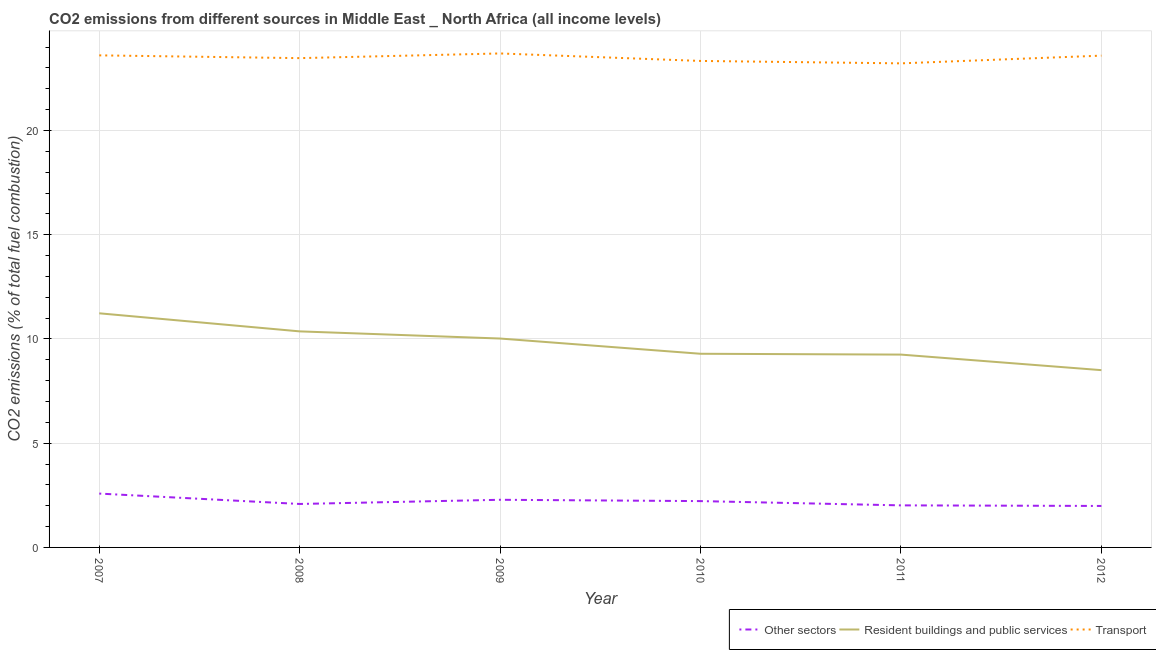Is the number of lines equal to the number of legend labels?
Ensure brevity in your answer.  Yes. What is the percentage of co2 emissions from resident buildings and public services in 2007?
Provide a succinct answer. 11.23. Across all years, what is the maximum percentage of co2 emissions from resident buildings and public services?
Provide a short and direct response. 11.23. Across all years, what is the minimum percentage of co2 emissions from resident buildings and public services?
Provide a succinct answer. 8.5. In which year was the percentage of co2 emissions from transport maximum?
Offer a terse response. 2009. In which year was the percentage of co2 emissions from transport minimum?
Offer a very short reply. 2011. What is the total percentage of co2 emissions from other sectors in the graph?
Provide a short and direct response. 13.18. What is the difference between the percentage of co2 emissions from transport in 2009 and that in 2011?
Make the answer very short. 0.48. What is the difference between the percentage of co2 emissions from other sectors in 2007 and the percentage of co2 emissions from transport in 2009?
Provide a succinct answer. -21.11. What is the average percentage of co2 emissions from other sectors per year?
Give a very brief answer. 2.2. In the year 2008, what is the difference between the percentage of co2 emissions from transport and percentage of co2 emissions from resident buildings and public services?
Offer a terse response. 13.11. What is the ratio of the percentage of co2 emissions from resident buildings and public services in 2009 to that in 2010?
Your answer should be very brief. 1.08. Is the percentage of co2 emissions from resident buildings and public services in 2007 less than that in 2011?
Ensure brevity in your answer.  No. Is the difference between the percentage of co2 emissions from other sectors in 2007 and 2009 greater than the difference between the percentage of co2 emissions from transport in 2007 and 2009?
Provide a succinct answer. Yes. What is the difference between the highest and the second highest percentage of co2 emissions from transport?
Make the answer very short. 0.09. What is the difference between the highest and the lowest percentage of co2 emissions from transport?
Keep it short and to the point. 0.48. In how many years, is the percentage of co2 emissions from resident buildings and public services greater than the average percentage of co2 emissions from resident buildings and public services taken over all years?
Provide a succinct answer. 3. Is it the case that in every year, the sum of the percentage of co2 emissions from other sectors and percentage of co2 emissions from resident buildings and public services is greater than the percentage of co2 emissions from transport?
Give a very brief answer. No. Does the percentage of co2 emissions from transport monotonically increase over the years?
Your answer should be very brief. No. Is the percentage of co2 emissions from transport strictly greater than the percentage of co2 emissions from other sectors over the years?
Offer a terse response. Yes. Is the percentage of co2 emissions from other sectors strictly less than the percentage of co2 emissions from transport over the years?
Provide a succinct answer. Yes. How many lines are there?
Ensure brevity in your answer.  3. What is the difference between two consecutive major ticks on the Y-axis?
Give a very brief answer. 5. Does the graph contain any zero values?
Ensure brevity in your answer.  No. Where does the legend appear in the graph?
Your answer should be very brief. Bottom right. How many legend labels are there?
Give a very brief answer. 3. What is the title of the graph?
Your response must be concise. CO2 emissions from different sources in Middle East _ North Africa (all income levels). What is the label or title of the X-axis?
Provide a succinct answer. Year. What is the label or title of the Y-axis?
Offer a terse response. CO2 emissions (% of total fuel combustion). What is the CO2 emissions (% of total fuel combustion) of Other sectors in 2007?
Provide a short and direct response. 2.58. What is the CO2 emissions (% of total fuel combustion) in Resident buildings and public services in 2007?
Your answer should be very brief. 11.23. What is the CO2 emissions (% of total fuel combustion) of Transport in 2007?
Your answer should be very brief. 23.6. What is the CO2 emissions (% of total fuel combustion) of Other sectors in 2008?
Your response must be concise. 2.08. What is the CO2 emissions (% of total fuel combustion) in Resident buildings and public services in 2008?
Make the answer very short. 10.36. What is the CO2 emissions (% of total fuel combustion) of Transport in 2008?
Your response must be concise. 23.47. What is the CO2 emissions (% of total fuel combustion) in Other sectors in 2009?
Give a very brief answer. 2.29. What is the CO2 emissions (% of total fuel combustion) of Resident buildings and public services in 2009?
Keep it short and to the point. 10.02. What is the CO2 emissions (% of total fuel combustion) in Transport in 2009?
Provide a succinct answer. 23.69. What is the CO2 emissions (% of total fuel combustion) in Other sectors in 2010?
Offer a terse response. 2.22. What is the CO2 emissions (% of total fuel combustion) in Resident buildings and public services in 2010?
Ensure brevity in your answer.  9.29. What is the CO2 emissions (% of total fuel combustion) of Transport in 2010?
Make the answer very short. 23.33. What is the CO2 emissions (% of total fuel combustion) in Other sectors in 2011?
Make the answer very short. 2.02. What is the CO2 emissions (% of total fuel combustion) in Resident buildings and public services in 2011?
Offer a terse response. 9.25. What is the CO2 emissions (% of total fuel combustion) of Transport in 2011?
Your answer should be compact. 23.22. What is the CO2 emissions (% of total fuel combustion) of Other sectors in 2012?
Offer a terse response. 1.99. What is the CO2 emissions (% of total fuel combustion) of Resident buildings and public services in 2012?
Make the answer very short. 8.5. What is the CO2 emissions (% of total fuel combustion) in Transport in 2012?
Your answer should be very brief. 23.59. Across all years, what is the maximum CO2 emissions (% of total fuel combustion) of Other sectors?
Your answer should be compact. 2.58. Across all years, what is the maximum CO2 emissions (% of total fuel combustion) in Resident buildings and public services?
Provide a succinct answer. 11.23. Across all years, what is the maximum CO2 emissions (% of total fuel combustion) in Transport?
Ensure brevity in your answer.  23.69. Across all years, what is the minimum CO2 emissions (% of total fuel combustion) of Other sectors?
Offer a terse response. 1.99. Across all years, what is the minimum CO2 emissions (% of total fuel combustion) of Resident buildings and public services?
Make the answer very short. 8.5. Across all years, what is the minimum CO2 emissions (% of total fuel combustion) in Transport?
Offer a very short reply. 23.22. What is the total CO2 emissions (% of total fuel combustion) of Other sectors in the graph?
Offer a very short reply. 13.18. What is the total CO2 emissions (% of total fuel combustion) in Resident buildings and public services in the graph?
Ensure brevity in your answer.  58.65. What is the total CO2 emissions (% of total fuel combustion) in Transport in the graph?
Provide a short and direct response. 140.91. What is the difference between the CO2 emissions (% of total fuel combustion) in Other sectors in 2007 and that in 2008?
Ensure brevity in your answer.  0.5. What is the difference between the CO2 emissions (% of total fuel combustion) in Resident buildings and public services in 2007 and that in 2008?
Your response must be concise. 0.87. What is the difference between the CO2 emissions (% of total fuel combustion) of Transport in 2007 and that in 2008?
Your response must be concise. 0.13. What is the difference between the CO2 emissions (% of total fuel combustion) in Other sectors in 2007 and that in 2009?
Keep it short and to the point. 0.3. What is the difference between the CO2 emissions (% of total fuel combustion) in Resident buildings and public services in 2007 and that in 2009?
Offer a very short reply. 1.21. What is the difference between the CO2 emissions (% of total fuel combustion) in Transport in 2007 and that in 2009?
Provide a succinct answer. -0.09. What is the difference between the CO2 emissions (% of total fuel combustion) in Other sectors in 2007 and that in 2010?
Your answer should be very brief. 0.36. What is the difference between the CO2 emissions (% of total fuel combustion) of Resident buildings and public services in 2007 and that in 2010?
Ensure brevity in your answer.  1.94. What is the difference between the CO2 emissions (% of total fuel combustion) in Transport in 2007 and that in 2010?
Keep it short and to the point. 0.27. What is the difference between the CO2 emissions (% of total fuel combustion) in Other sectors in 2007 and that in 2011?
Your answer should be very brief. 0.56. What is the difference between the CO2 emissions (% of total fuel combustion) of Resident buildings and public services in 2007 and that in 2011?
Offer a terse response. 1.98. What is the difference between the CO2 emissions (% of total fuel combustion) of Transport in 2007 and that in 2011?
Give a very brief answer. 0.38. What is the difference between the CO2 emissions (% of total fuel combustion) of Other sectors in 2007 and that in 2012?
Offer a terse response. 0.59. What is the difference between the CO2 emissions (% of total fuel combustion) of Resident buildings and public services in 2007 and that in 2012?
Provide a short and direct response. 2.73. What is the difference between the CO2 emissions (% of total fuel combustion) of Transport in 2007 and that in 2012?
Ensure brevity in your answer.  0.01. What is the difference between the CO2 emissions (% of total fuel combustion) of Other sectors in 2008 and that in 2009?
Provide a succinct answer. -0.2. What is the difference between the CO2 emissions (% of total fuel combustion) in Resident buildings and public services in 2008 and that in 2009?
Make the answer very short. 0.34. What is the difference between the CO2 emissions (% of total fuel combustion) of Transport in 2008 and that in 2009?
Offer a terse response. -0.22. What is the difference between the CO2 emissions (% of total fuel combustion) in Other sectors in 2008 and that in 2010?
Your response must be concise. -0.14. What is the difference between the CO2 emissions (% of total fuel combustion) in Resident buildings and public services in 2008 and that in 2010?
Provide a succinct answer. 1.07. What is the difference between the CO2 emissions (% of total fuel combustion) of Transport in 2008 and that in 2010?
Keep it short and to the point. 0.13. What is the difference between the CO2 emissions (% of total fuel combustion) of Other sectors in 2008 and that in 2011?
Your answer should be compact. 0.07. What is the difference between the CO2 emissions (% of total fuel combustion) in Resident buildings and public services in 2008 and that in 2011?
Offer a terse response. 1.11. What is the difference between the CO2 emissions (% of total fuel combustion) in Transport in 2008 and that in 2011?
Make the answer very short. 0.25. What is the difference between the CO2 emissions (% of total fuel combustion) of Other sectors in 2008 and that in 2012?
Give a very brief answer. 0.1. What is the difference between the CO2 emissions (% of total fuel combustion) of Resident buildings and public services in 2008 and that in 2012?
Give a very brief answer. 1.86. What is the difference between the CO2 emissions (% of total fuel combustion) in Transport in 2008 and that in 2012?
Offer a very short reply. -0.12. What is the difference between the CO2 emissions (% of total fuel combustion) in Other sectors in 2009 and that in 2010?
Your response must be concise. 0.06. What is the difference between the CO2 emissions (% of total fuel combustion) of Resident buildings and public services in 2009 and that in 2010?
Make the answer very short. 0.73. What is the difference between the CO2 emissions (% of total fuel combustion) in Transport in 2009 and that in 2010?
Provide a short and direct response. 0.36. What is the difference between the CO2 emissions (% of total fuel combustion) in Other sectors in 2009 and that in 2011?
Provide a succinct answer. 0.27. What is the difference between the CO2 emissions (% of total fuel combustion) in Resident buildings and public services in 2009 and that in 2011?
Keep it short and to the point. 0.77. What is the difference between the CO2 emissions (% of total fuel combustion) in Transport in 2009 and that in 2011?
Your response must be concise. 0.48. What is the difference between the CO2 emissions (% of total fuel combustion) in Other sectors in 2009 and that in 2012?
Your answer should be very brief. 0.3. What is the difference between the CO2 emissions (% of total fuel combustion) of Resident buildings and public services in 2009 and that in 2012?
Give a very brief answer. 1.52. What is the difference between the CO2 emissions (% of total fuel combustion) of Transport in 2009 and that in 2012?
Your answer should be very brief. 0.1. What is the difference between the CO2 emissions (% of total fuel combustion) of Other sectors in 2010 and that in 2011?
Provide a short and direct response. 0.2. What is the difference between the CO2 emissions (% of total fuel combustion) in Resident buildings and public services in 2010 and that in 2011?
Your answer should be very brief. 0.04. What is the difference between the CO2 emissions (% of total fuel combustion) in Transport in 2010 and that in 2011?
Keep it short and to the point. 0.12. What is the difference between the CO2 emissions (% of total fuel combustion) in Other sectors in 2010 and that in 2012?
Give a very brief answer. 0.23. What is the difference between the CO2 emissions (% of total fuel combustion) of Resident buildings and public services in 2010 and that in 2012?
Offer a very short reply. 0.79. What is the difference between the CO2 emissions (% of total fuel combustion) in Transport in 2010 and that in 2012?
Offer a terse response. -0.25. What is the difference between the CO2 emissions (% of total fuel combustion) in Other sectors in 2011 and that in 2012?
Offer a very short reply. 0.03. What is the difference between the CO2 emissions (% of total fuel combustion) in Resident buildings and public services in 2011 and that in 2012?
Keep it short and to the point. 0.75. What is the difference between the CO2 emissions (% of total fuel combustion) in Transport in 2011 and that in 2012?
Offer a terse response. -0.37. What is the difference between the CO2 emissions (% of total fuel combustion) in Other sectors in 2007 and the CO2 emissions (% of total fuel combustion) in Resident buildings and public services in 2008?
Provide a succinct answer. -7.78. What is the difference between the CO2 emissions (% of total fuel combustion) in Other sectors in 2007 and the CO2 emissions (% of total fuel combustion) in Transport in 2008?
Your response must be concise. -20.89. What is the difference between the CO2 emissions (% of total fuel combustion) of Resident buildings and public services in 2007 and the CO2 emissions (% of total fuel combustion) of Transport in 2008?
Offer a terse response. -12.24. What is the difference between the CO2 emissions (% of total fuel combustion) of Other sectors in 2007 and the CO2 emissions (% of total fuel combustion) of Resident buildings and public services in 2009?
Make the answer very short. -7.44. What is the difference between the CO2 emissions (% of total fuel combustion) in Other sectors in 2007 and the CO2 emissions (% of total fuel combustion) in Transport in 2009?
Offer a terse response. -21.11. What is the difference between the CO2 emissions (% of total fuel combustion) of Resident buildings and public services in 2007 and the CO2 emissions (% of total fuel combustion) of Transport in 2009?
Make the answer very short. -12.46. What is the difference between the CO2 emissions (% of total fuel combustion) in Other sectors in 2007 and the CO2 emissions (% of total fuel combustion) in Resident buildings and public services in 2010?
Offer a very short reply. -6.71. What is the difference between the CO2 emissions (% of total fuel combustion) in Other sectors in 2007 and the CO2 emissions (% of total fuel combustion) in Transport in 2010?
Give a very brief answer. -20.75. What is the difference between the CO2 emissions (% of total fuel combustion) of Resident buildings and public services in 2007 and the CO2 emissions (% of total fuel combustion) of Transport in 2010?
Keep it short and to the point. -12.1. What is the difference between the CO2 emissions (% of total fuel combustion) of Other sectors in 2007 and the CO2 emissions (% of total fuel combustion) of Resident buildings and public services in 2011?
Offer a very short reply. -6.67. What is the difference between the CO2 emissions (% of total fuel combustion) in Other sectors in 2007 and the CO2 emissions (% of total fuel combustion) in Transport in 2011?
Your answer should be compact. -20.64. What is the difference between the CO2 emissions (% of total fuel combustion) in Resident buildings and public services in 2007 and the CO2 emissions (% of total fuel combustion) in Transport in 2011?
Provide a succinct answer. -11.99. What is the difference between the CO2 emissions (% of total fuel combustion) of Other sectors in 2007 and the CO2 emissions (% of total fuel combustion) of Resident buildings and public services in 2012?
Your answer should be compact. -5.92. What is the difference between the CO2 emissions (% of total fuel combustion) in Other sectors in 2007 and the CO2 emissions (% of total fuel combustion) in Transport in 2012?
Offer a very short reply. -21.01. What is the difference between the CO2 emissions (% of total fuel combustion) in Resident buildings and public services in 2007 and the CO2 emissions (% of total fuel combustion) in Transport in 2012?
Your answer should be very brief. -12.36. What is the difference between the CO2 emissions (% of total fuel combustion) in Other sectors in 2008 and the CO2 emissions (% of total fuel combustion) in Resident buildings and public services in 2009?
Your answer should be very brief. -7.94. What is the difference between the CO2 emissions (% of total fuel combustion) in Other sectors in 2008 and the CO2 emissions (% of total fuel combustion) in Transport in 2009?
Your response must be concise. -21.61. What is the difference between the CO2 emissions (% of total fuel combustion) of Resident buildings and public services in 2008 and the CO2 emissions (% of total fuel combustion) of Transport in 2009?
Make the answer very short. -13.33. What is the difference between the CO2 emissions (% of total fuel combustion) of Other sectors in 2008 and the CO2 emissions (% of total fuel combustion) of Resident buildings and public services in 2010?
Provide a short and direct response. -7.2. What is the difference between the CO2 emissions (% of total fuel combustion) in Other sectors in 2008 and the CO2 emissions (% of total fuel combustion) in Transport in 2010?
Your answer should be very brief. -21.25. What is the difference between the CO2 emissions (% of total fuel combustion) in Resident buildings and public services in 2008 and the CO2 emissions (% of total fuel combustion) in Transport in 2010?
Provide a short and direct response. -12.97. What is the difference between the CO2 emissions (% of total fuel combustion) in Other sectors in 2008 and the CO2 emissions (% of total fuel combustion) in Resident buildings and public services in 2011?
Offer a very short reply. -7.16. What is the difference between the CO2 emissions (% of total fuel combustion) of Other sectors in 2008 and the CO2 emissions (% of total fuel combustion) of Transport in 2011?
Offer a terse response. -21.13. What is the difference between the CO2 emissions (% of total fuel combustion) of Resident buildings and public services in 2008 and the CO2 emissions (% of total fuel combustion) of Transport in 2011?
Give a very brief answer. -12.86. What is the difference between the CO2 emissions (% of total fuel combustion) in Other sectors in 2008 and the CO2 emissions (% of total fuel combustion) in Resident buildings and public services in 2012?
Offer a terse response. -6.42. What is the difference between the CO2 emissions (% of total fuel combustion) of Other sectors in 2008 and the CO2 emissions (% of total fuel combustion) of Transport in 2012?
Offer a very short reply. -21.5. What is the difference between the CO2 emissions (% of total fuel combustion) in Resident buildings and public services in 2008 and the CO2 emissions (% of total fuel combustion) in Transport in 2012?
Provide a succinct answer. -13.23. What is the difference between the CO2 emissions (% of total fuel combustion) of Other sectors in 2009 and the CO2 emissions (% of total fuel combustion) of Resident buildings and public services in 2010?
Offer a very short reply. -7. What is the difference between the CO2 emissions (% of total fuel combustion) of Other sectors in 2009 and the CO2 emissions (% of total fuel combustion) of Transport in 2010?
Make the answer very short. -21.05. What is the difference between the CO2 emissions (% of total fuel combustion) in Resident buildings and public services in 2009 and the CO2 emissions (% of total fuel combustion) in Transport in 2010?
Your answer should be very brief. -13.31. What is the difference between the CO2 emissions (% of total fuel combustion) in Other sectors in 2009 and the CO2 emissions (% of total fuel combustion) in Resident buildings and public services in 2011?
Ensure brevity in your answer.  -6.96. What is the difference between the CO2 emissions (% of total fuel combustion) in Other sectors in 2009 and the CO2 emissions (% of total fuel combustion) in Transport in 2011?
Provide a succinct answer. -20.93. What is the difference between the CO2 emissions (% of total fuel combustion) of Resident buildings and public services in 2009 and the CO2 emissions (% of total fuel combustion) of Transport in 2011?
Make the answer very short. -13.2. What is the difference between the CO2 emissions (% of total fuel combustion) of Other sectors in 2009 and the CO2 emissions (% of total fuel combustion) of Resident buildings and public services in 2012?
Keep it short and to the point. -6.22. What is the difference between the CO2 emissions (% of total fuel combustion) of Other sectors in 2009 and the CO2 emissions (% of total fuel combustion) of Transport in 2012?
Provide a succinct answer. -21.3. What is the difference between the CO2 emissions (% of total fuel combustion) of Resident buildings and public services in 2009 and the CO2 emissions (% of total fuel combustion) of Transport in 2012?
Ensure brevity in your answer.  -13.57. What is the difference between the CO2 emissions (% of total fuel combustion) of Other sectors in 2010 and the CO2 emissions (% of total fuel combustion) of Resident buildings and public services in 2011?
Ensure brevity in your answer.  -7.03. What is the difference between the CO2 emissions (% of total fuel combustion) in Other sectors in 2010 and the CO2 emissions (% of total fuel combustion) in Transport in 2011?
Offer a terse response. -21. What is the difference between the CO2 emissions (% of total fuel combustion) in Resident buildings and public services in 2010 and the CO2 emissions (% of total fuel combustion) in Transport in 2011?
Offer a terse response. -13.93. What is the difference between the CO2 emissions (% of total fuel combustion) of Other sectors in 2010 and the CO2 emissions (% of total fuel combustion) of Resident buildings and public services in 2012?
Ensure brevity in your answer.  -6.28. What is the difference between the CO2 emissions (% of total fuel combustion) in Other sectors in 2010 and the CO2 emissions (% of total fuel combustion) in Transport in 2012?
Make the answer very short. -21.37. What is the difference between the CO2 emissions (% of total fuel combustion) in Resident buildings and public services in 2010 and the CO2 emissions (% of total fuel combustion) in Transport in 2012?
Provide a short and direct response. -14.3. What is the difference between the CO2 emissions (% of total fuel combustion) of Other sectors in 2011 and the CO2 emissions (% of total fuel combustion) of Resident buildings and public services in 2012?
Offer a very short reply. -6.49. What is the difference between the CO2 emissions (% of total fuel combustion) of Other sectors in 2011 and the CO2 emissions (% of total fuel combustion) of Transport in 2012?
Make the answer very short. -21.57. What is the difference between the CO2 emissions (% of total fuel combustion) of Resident buildings and public services in 2011 and the CO2 emissions (% of total fuel combustion) of Transport in 2012?
Give a very brief answer. -14.34. What is the average CO2 emissions (% of total fuel combustion) in Other sectors per year?
Your answer should be compact. 2.2. What is the average CO2 emissions (% of total fuel combustion) of Resident buildings and public services per year?
Your response must be concise. 9.78. What is the average CO2 emissions (% of total fuel combustion) of Transport per year?
Offer a very short reply. 23.48. In the year 2007, what is the difference between the CO2 emissions (% of total fuel combustion) in Other sectors and CO2 emissions (% of total fuel combustion) in Resident buildings and public services?
Ensure brevity in your answer.  -8.65. In the year 2007, what is the difference between the CO2 emissions (% of total fuel combustion) of Other sectors and CO2 emissions (% of total fuel combustion) of Transport?
Offer a very short reply. -21.02. In the year 2007, what is the difference between the CO2 emissions (% of total fuel combustion) of Resident buildings and public services and CO2 emissions (% of total fuel combustion) of Transport?
Provide a succinct answer. -12.37. In the year 2008, what is the difference between the CO2 emissions (% of total fuel combustion) in Other sectors and CO2 emissions (% of total fuel combustion) in Resident buildings and public services?
Offer a very short reply. -8.28. In the year 2008, what is the difference between the CO2 emissions (% of total fuel combustion) of Other sectors and CO2 emissions (% of total fuel combustion) of Transport?
Provide a succinct answer. -21.38. In the year 2008, what is the difference between the CO2 emissions (% of total fuel combustion) of Resident buildings and public services and CO2 emissions (% of total fuel combustion) of Transport?
Give a very brief answer. -13.11. In the year 2009, what is the difference between the CO2 emissions (% of total fuel combustion) of Other sectors and CO2 emissions (% of total fuel combustion) of Resident buildings and public services?
Offer a terse response. -7.73. In the year 2009, what is the difference between the CO2 emissions (% of total fuel combustion) in Other sectors and CO2 emissions (% of total fuel combustion) in Transport?
Offer a terse response. -21.41. In the year 2009, what is the difference between the CO2 emissions (% of total fuel combustion) in Resident buildings and public services and CO2 emissions (% of total fuel combustion) in Transport?
Provide a succinct answer. -13.67. In the year 2010, what is the difference between the CO2 emissions (% of total fuel combustion) of Other sectors and CO2 emissions (% of total fuel combustion) of Resident buildings and public services?
Your answer should be very brief. -7.07. In the year 2010, what is the difference between the CO2 emissions (% of total fuel combustion) of Other sectors and CO2 emissions (% of total fuel combustion) of Transport?
Your answer should be compact. -21.11. In the year 2010, what is the difference between the CO2 emissions (% of total fuel combustion) in Resident buildings and public services and CO2 emissions (% of total fuel combustion) in Transport?
Your answer should be very brief. -14.05. In the year 2011, what is the difference between the CO2 emissions (% of total fuel combustion) of Other sectors and CO2 emissions (% of total fuel combustion) of Resident buildings and public services?
Offer a terse response. -7.23. In the year 2011, what is the difference between the CO2 emissions (% of total fuel combustion) in Other sectors and CO2 emissions (% of total fuel combustion) in Transport?
Your response must be concise. -21.2. In the year 2011, what is the difference between the CO2 emissions (% of total fuel combustion) of Resident buildings and public services and CO2 emissions (% of total fuel combustion) of Transport?
Your response must be concise. -13.97. In the year 2012, what is the difference between the CO2 emissions (% of total fuel combustion) in Other sectors and CO2 emissions (% of total fuel combustion) in Resident buildings and public services?
Provide a short and direct response. -6.51. In the year 2012, what is the difference between the CO2 emissions (% of total fuel combustion) of Other sectors and CO2 emissions (% of total fuel combustion) of Transport?
Offer a very short reply. -21.6. In the year 2012, what is the difference between the CO2 emissions (% of total fuel combustion) in Resident buildings and public services and CO2 emissions (% of total fuel combustion) in Transport?
Provide a succinct answer. -15.09. What is the ratio of the CO2 emissions (% of total fuel combustion) in Other sectors in 2007 to that in 2008?
Give a very brief answer. 1.24. What is the ratio of the CO2 emissions (% of total fuel combustion) in Resident buildings and public services in 2007 to that in 2008?
Your answer should be compact. 1.08. What is the ratio of the CO2 emissions (% of total fuel combustion) of Other sectors in 2007 to that in 2009?
Ensure brevity in your answer.  1.13. What is the ratio of the CO2 emissions (% of total fuel combustion) in Resident buildings and public services in 2007 to that in 2009?
Your answer should be very brief. 1.12. What is the ratio of the CO2 emissions (% of total fuel combustion) in Transport in 2007 to that in 2009?
Your response must be concise. 1. What is the ratio of the CO2 emissions (% of total fuel combustion) in Other sectors in 2007 to that in 2010?
Keep it short and to the point. 1.16. What is the ratio of the CO2 emissions (% of total fuel combustion) in Resident buildings and public services in 2007 to that in 2010?
Give a very brief answer. 1.21. What is the ratio of the CO2 emissions (% of total fuel combustion) of Transport in 2007 to that in 2010?
Offer a terse response. 1.01. What is the ratio of the CO2 emissions (% of total fuel combustion) in Other sectors in 2007 to that in 2011?
Keep it short and to the point. 1.28. What is the ratio of the CO2 emissions (% of total fuel combustion) of Resident buildings and public services in 2007 to that in 2011?
Provide a short and direct response. 1.21. What is the ratio of the CO2 emissions (% of total fuel combustion) in Transport in 2007 to that in 2011?
Provide a succinct answer. 1.02. What is the ratio of the CO2 emissions (% of total fuel combustion) of Other sectors in 2007 to that in 2012?
Provide a succinct answer. 1.3. What is the ratio of the CO2 emissions (% of total fuel combustion) in Resident buildings and public services in 2007 to that in 2012?
Offer a very short reply. 1.32. What is the ratio of the CO2 emissions (% of total fuel combustion) in Transport in 2007 to that in 2012?
Your answer should be very brief. 1. What is the ratio of the CO2 emissions (% of total fuel combustion) of Other sectors in 2008 to that in 2009?
Your answer should be very brief. 0.91. What is the ratio of the CO2 emissions (% of total fuel combustion) in Resident buildings and public services in 2008 to that in 2009?
Make the answer very short. 1.03. What is the ratio of the CO2 emissions (% of total fuel combustion) in Transport in 2008 to that in 2009?
Keep it short and to the point. 0.99. What is the ratio of the CO2 emissions (% of total fuel combustion) in Other sectors in 2008 to that in 2010?
Give a very brief answer. 0.94. What is the ratio of the CO2 emissions (% of total fuel combustion) in Resident buildings and public services in 2008 to that in 2010?
Your answer should be very brief. 1.12. What is the ratio of the CO2 emissions (% of total fuel combustion) in Other sectors in 2008 to that in 2011?
Your answer should be compact. 1.03. What is the ratio of the CO2 emissions (% of total fuel combustion) in Resident buildings and public services in 2008 to that in 2011?
Your answer should be very brief. 1.12. What is the ratio of the CO2 emissions (% of total fuel combustion) in Transport in 2008 to that in 2011?
Provide a short and direct response. 1.01. What is the ratio of the CO2 emissions (% of total fuel combustion) of Other sectors in 2008 to that in 2012?
Offer a terse response. 1.05. What is the ratio of the CO2 emissions (% of total fuel combustion) in Resident buildings and public services in 2008 to that in 2012?
Offer a very short reply. 1.22. What is the ratio of the CO2 emissions (% of total fuel combustion) in Other sectors in 2009 to that in 2010?
Your answer should be compact. 1.03. What is the ratio of the CO2 emissions (% of total fuel combustion) of Resident buildings and public services in 2009 to that in 2010?
Give a very brief answer. 1.08. What is the ratio of the CO2 emissions (% of total fuel combustion) of Transport in 2009 to that in 2010?
Offer a very short reply. 1.02. What is the ratio of the CO2 emissions (% of total fuel combustion) of Other sectors in 2009 to that in 2011?
Your response must be concise. 1.13. What is the ratio of the CO2 emissions (% of total fuel combustion) of Resident buildings and public services in 2009 to that in 2011?
Give a very brief answer. 1.08. What is the ratio of the CO2 emissions (% of total fuel combustion) of Transport in 2009 to that in 2011?
Provide a short and direct response. 1.02. What is the ratio of the CO2 emissions (% of total fuel combustion) of Other sectors in 2009 to that in 2012?
Keep it short and to the point. 1.15. What is the ratio of the CO2 emissions (% of total fuel combustion) of Resident buildings and public services in 2009 to that in 2012?
Ensure brevity in your answer.  1.18. What is the ratio of the CO2 emissions (% of total fuel combustion) of Transport in 2009 to that in 2012?
Give a very brief answer. 1. What is the ratio of the CO2 emissions (% of total fuel combustion) in Other sectors in 2010 to that in 2011?
Give a very brief answer. 1.1. What is the ratio of the CO2 emissions (% of total fuel combustion) in Transport in 2010 to that in 2011?
Offer a terse response. 1. What is the ratio of the CO2 emissions (% of total fuel combustion) of Other sectors in 2010 to that in 2012?
Ensure brevity in your answer.  1.12. What is the ratio of the CO2 emissions (% of total fuel combustion) of Resident buildings and public services in 2010 to that in 2012?
Offer a very short reply. 1.09. What is the ratio of the CO2 emissions (% of total fuel combustion) in Other sectors in 2011 to that in 2012?
Give a very brief answer. 1.01. What is the ratio of the CO2 emissions (% of total fuel combustion) in Resident buildings and public services in 2011 to that in 2012?
Your answer should be compact. 1.09. What is the ratio of the CO2 emissions (% of total fuel combustion) in Transport in 2011 to that in 2012?
Your answer should be very brief. 0.98. What is the difference between the highest and the second highest CO2 emissions (% of total fuel combustion) of Other sectors?
Provide a short and direct response. 0.3. What is the difference between the highest and the second highest CO2 emissions (% of total fuel combustion) in Resident buildings and public services?
Offer a terse response. 0.87. What is the difference between the highest and the second highest CO2 emissions (% of total fuel combustion) of Transport?
Ensure brevity in your answer.  0.09. What is the difference between the highest and the lowest CO2 emissions (% of total fuel combustion) of Other sectors?
Offer a very short reply. 0.59. What is the difference between the highest and the lowest CO2 emissions (% of total fuel combustion) in Resident buildings and public services?
Give a very brief answer. 2.73. What is the difference between the highest and the lowest CO2 emissions (% of total fuel combustion) in Transport?
Keep it short and to the point. 0.48. 